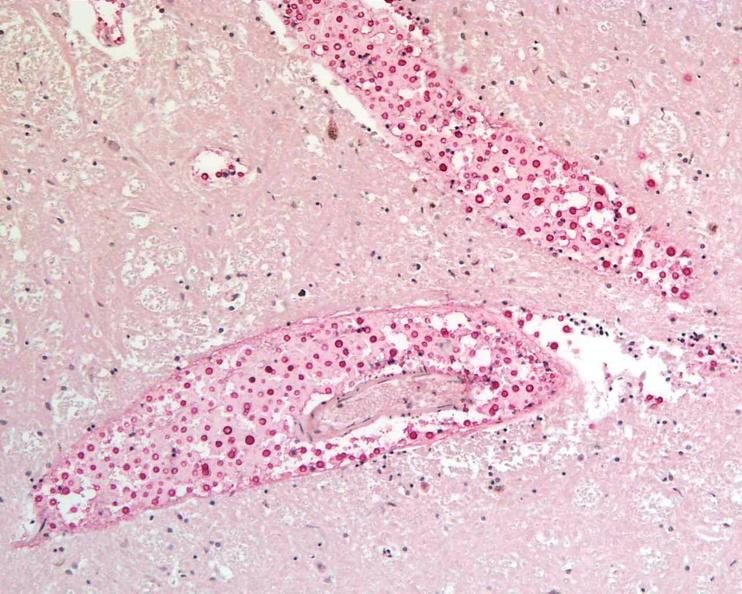where is this?
Answer the question using a single word or phrase. Nervous 